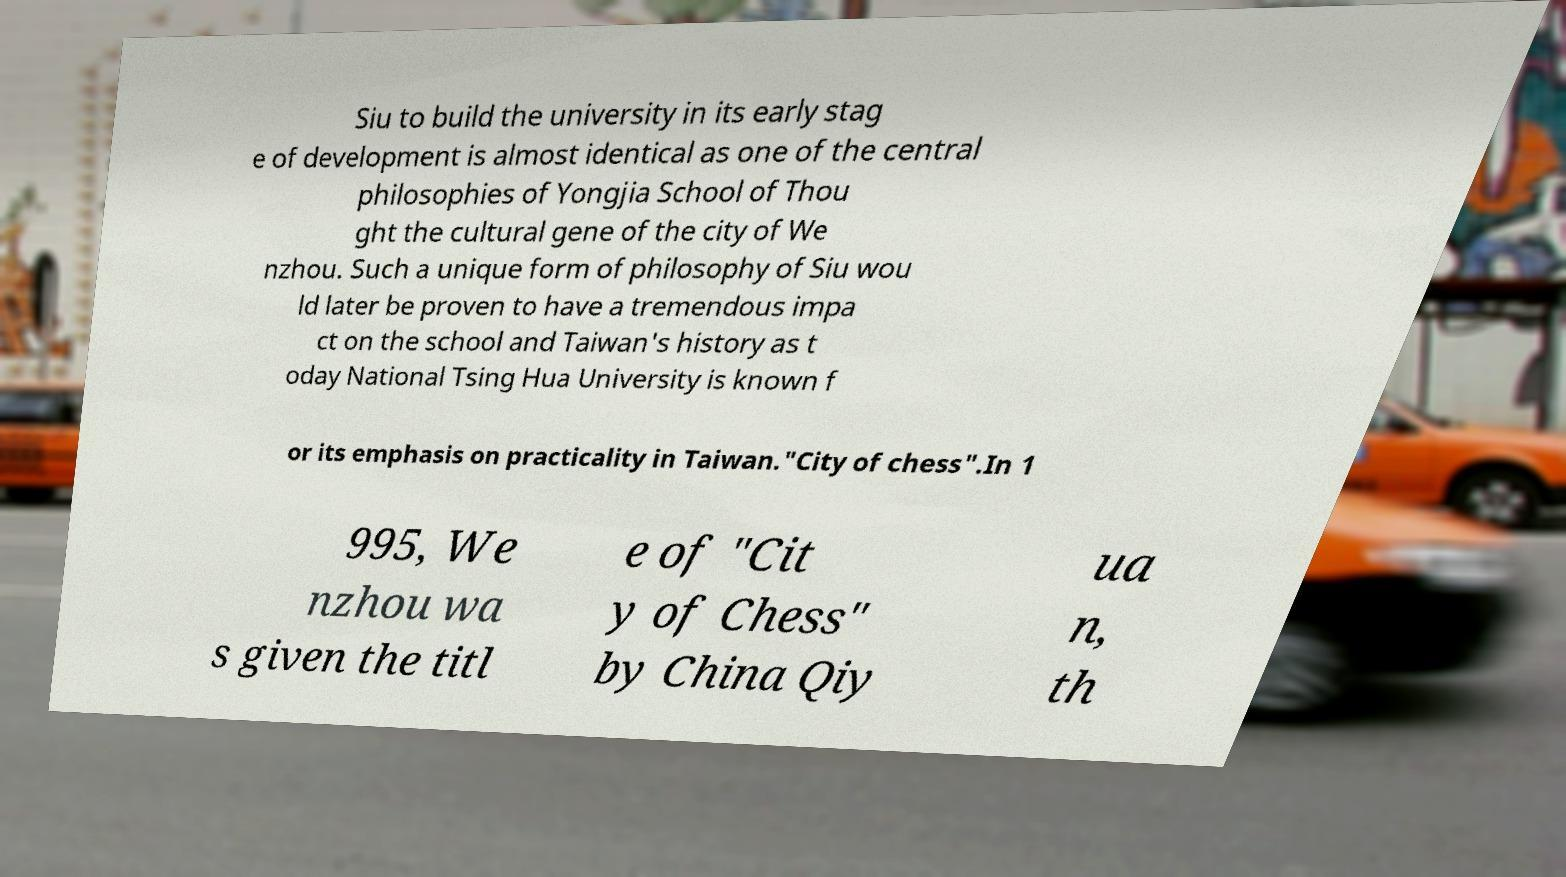What messages or text are displayed in this image? I need them in a readable, typed format. Siu to build the university in its early stag e of development is almost identical as one of the central philosophies of Yongjia School of Thou ght the cultural gene of the city of We nzhou. Such a unique form of philosophy of Siu wou ld later be proven to have a tremendous impa ct on the school and Taiwan's history as t oday National Tsing Hua University is known f or its emphasis on practicality in Taiwan."City of chess".In 1 995, We nzhou wa s given the titl e of "Cit y of Chess" by China Qiy ua n, th 